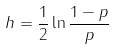Convert formula to latex. <formula><loc_0><loc_0><loc_500><loc_500>h = \frac { 1 } { 2 } \ln \frac { 1 - p } { p }</formula> 